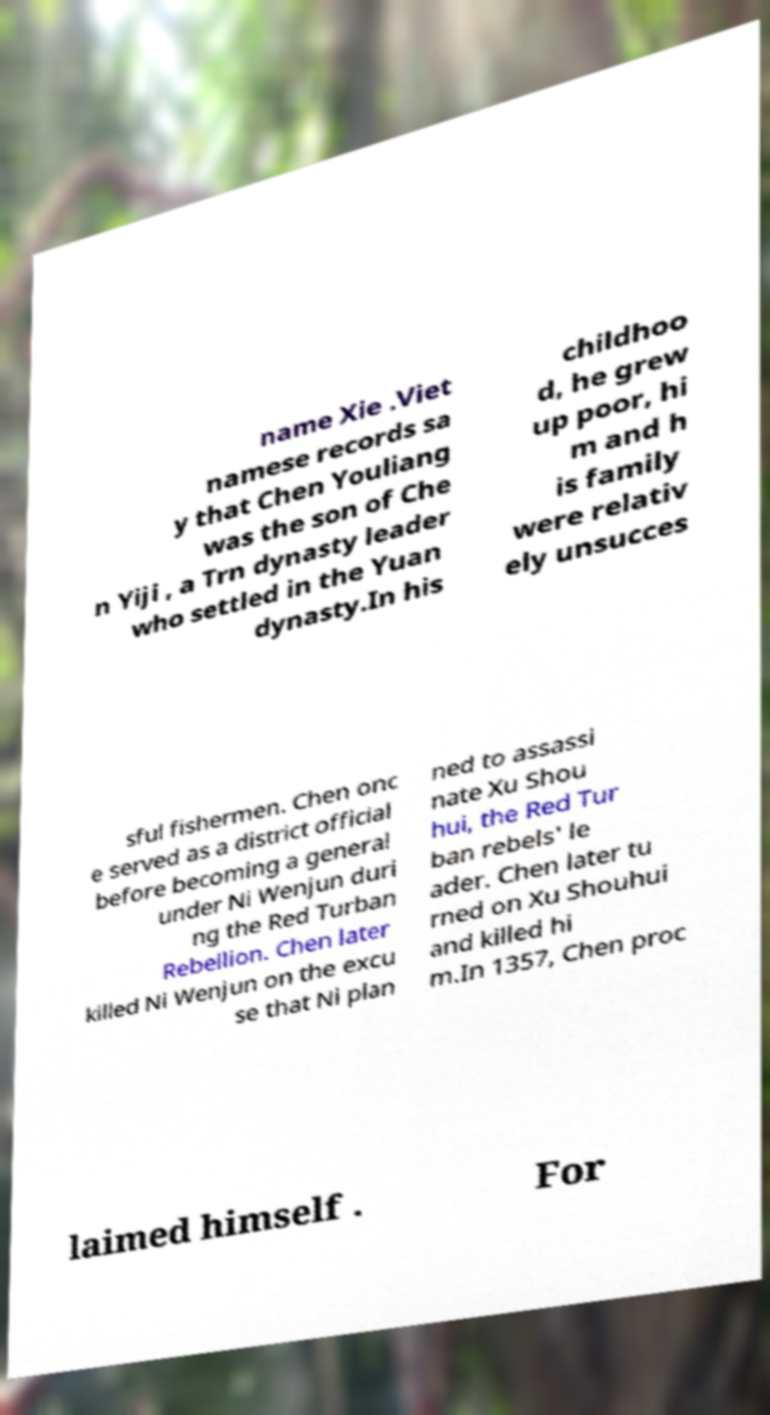Could you extract and type out the text from this image? name Xie .Viet namese records sa y that Chen Youliang was the son of Che n Yiji , a Trn dynasty leader who settled in the Yuan dynasty.In his childhoo d, he grew up poor, hi m and h is family were relativ ely unsucces sful fishermen. Chen onc e served as a district official before becoming a general under Ni Wenjun duri ng the Red Turban Rebellion. Chen later killed Ni Wenjun on the excu se that Ni plan ned to assassi nate Xu Shou hui, the Red Tur ban rebels' le ader. Chen later tu rned on Xu Shouhui and killed hi m.In 1357, Chen proc laimed himself . For 